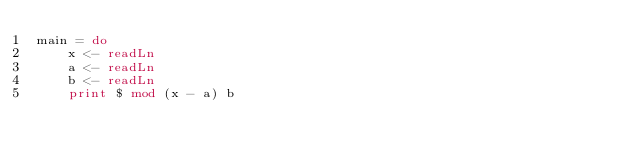Convert code to text. <code><loc_0><loc_0><loc_500><loc_500><_Haskell_>main = do
    x <- readLn
    a <- readLn
    b <- readLn
    print $ mod (x - a) b
        </code> 